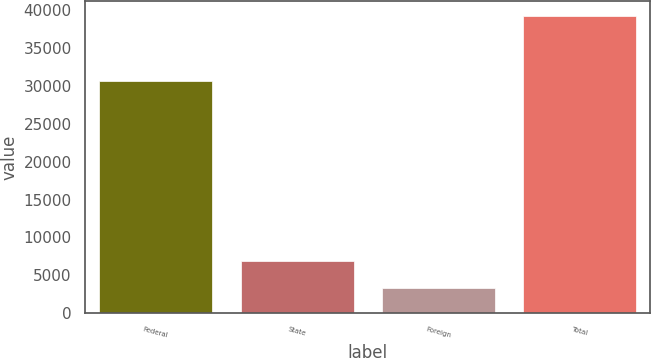<chart> <loc_0><loc_0><loc_500><loc_500><bar_chart><fcel>Federal<fcel>State<fcel>Foreign<fcel>Total<nl><fcel>30660<fcel>6857.4<fcel>3254<fcel>39288<nl></chart> 